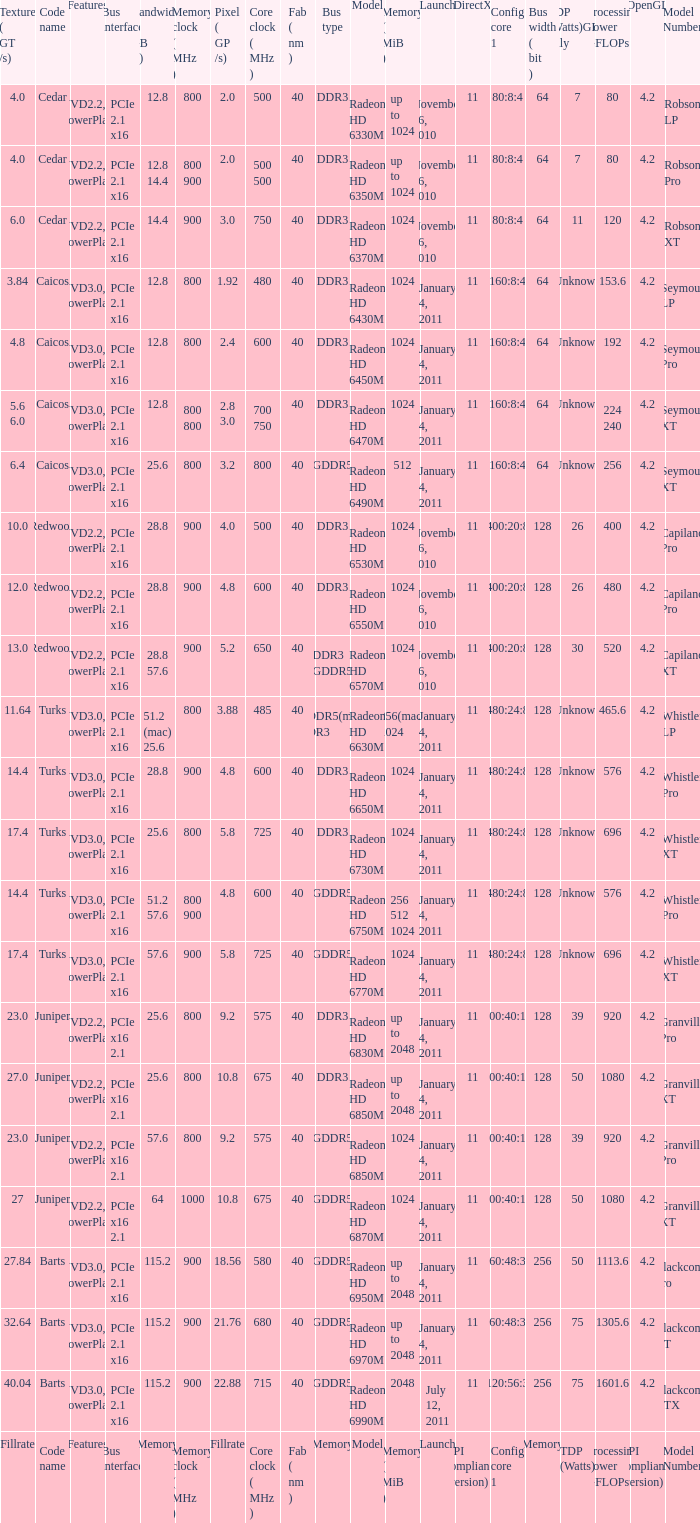What is the value for congi core 1 if the code name is Redwood and core clock(mhz) is 500? 400:20:8. 